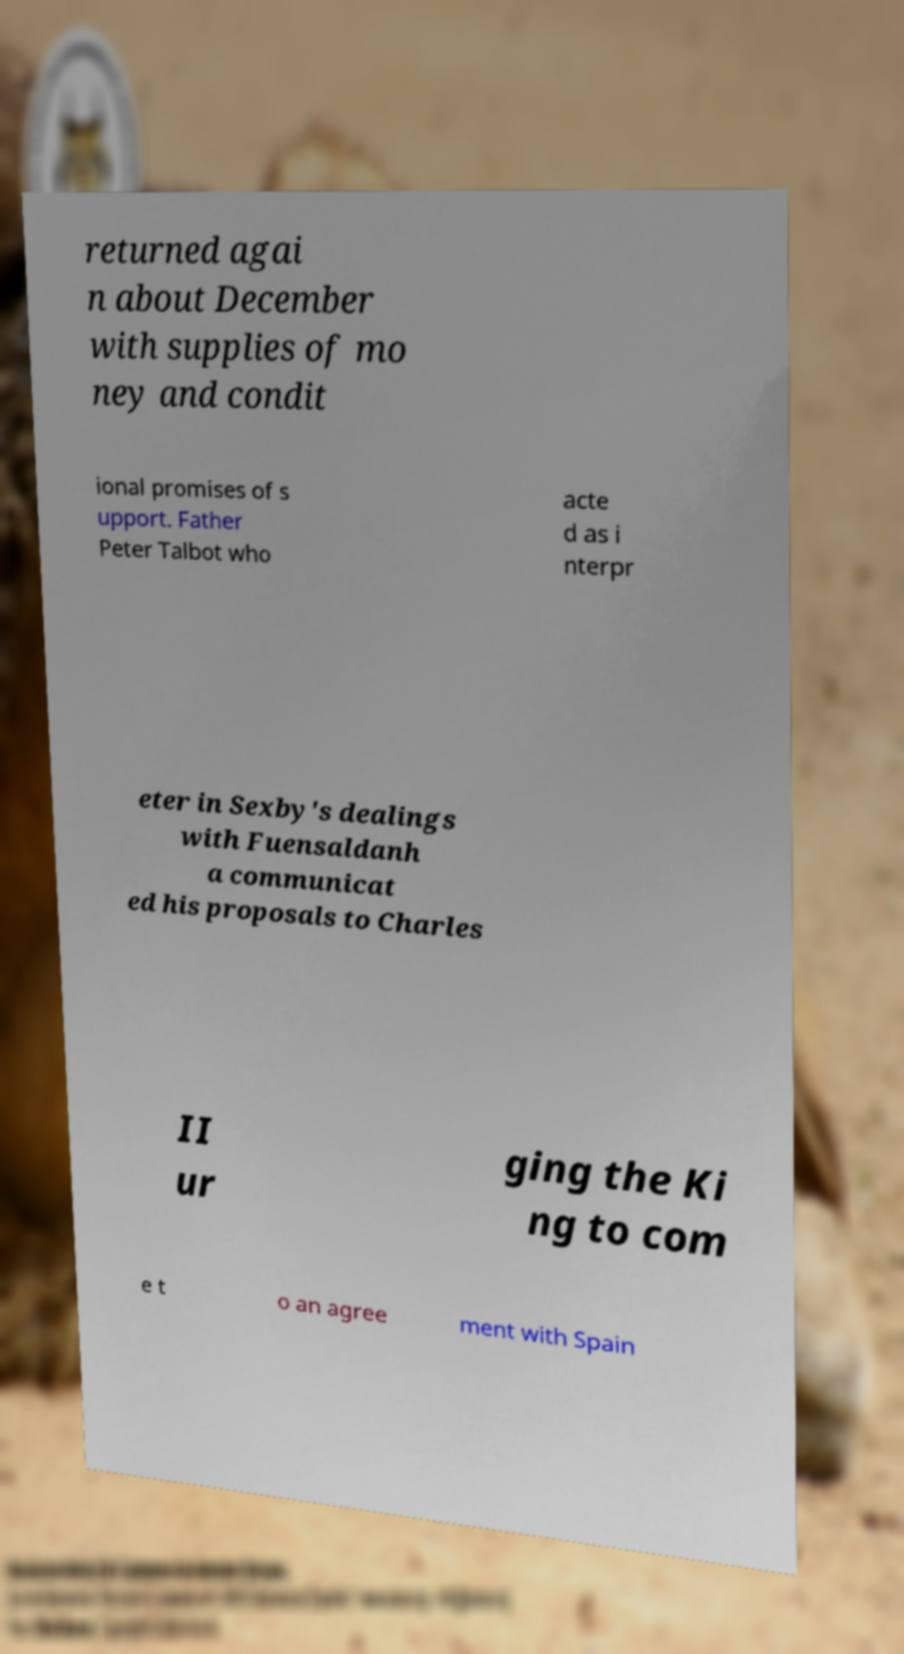There's text embedded in this image that I need extracted. Can you transcribe it verbatim? returned agai n about December with supplies of mo ney and condit ional promises of s upport. Father Peter Talbot who acte d as i nterpr eter in Sexby's dealings with Fuensaldanh a communicat ed his proposals to Charles II ur ging the Ki ng to com e t o an agree ment with Spain 